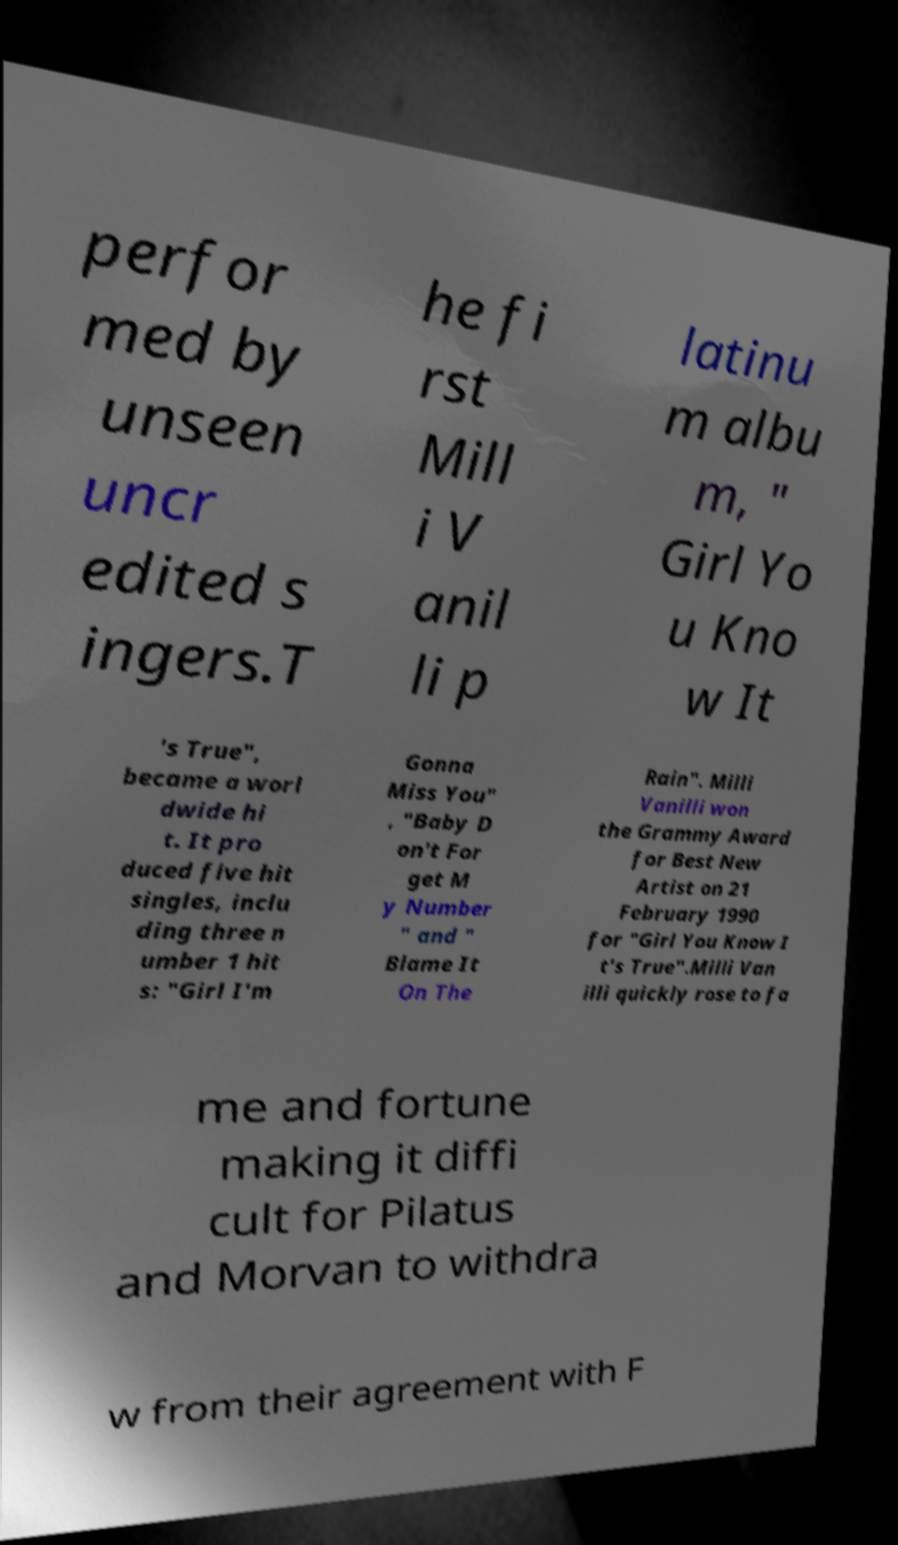Please identify and transcribe the text found in this image. perfor med by unseen uncr edited s ingers.T he fi rst Mill i V anil li p latinu m albu m, " Girl Yo u Kno w It 's True", became a worl dwide hi t. It pro duced five hit singles, inclu ding three n umber 1 hit s: "Girl I'm Gonna Miss You" , "Baby D on't For get M y Number " and " Blame It On The Rain". Milli Vanilli won the Grammy Award for Best New Artist on 21 February 1990 for "Girl You Know I t's True".Milli Van illi quickly rose to fa me and fortune making it diffi cult for Pilatus and Morvan to withdra w from their agreement with F 